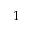Convert formula to latex. <formula><loc_0><loc_0><loc_500><loc_500>1</formula> 